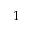Convert formula to latex. <formula><loc_0><loc_0><loc_500><loc_500>1</formula> 